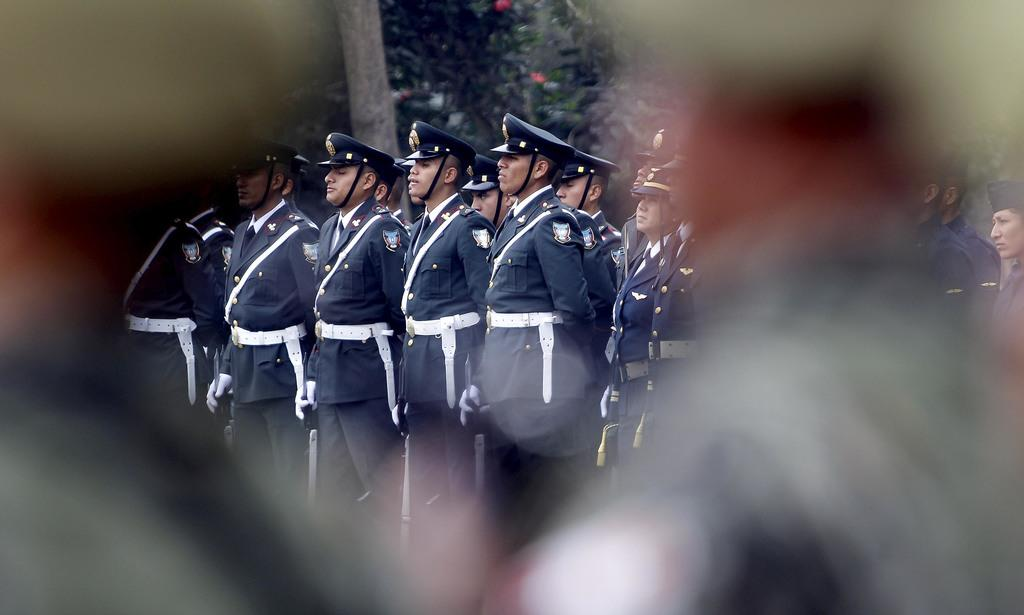Who or what can be seen in the image? There are people in the image. What are the people wearing? The people are wearing uniforms. What can be seen in the distance behind the people? There are trees in the background of the image. What type of yak is grazing in the foreground of the image? There is no yak present in the image; it features people wearing uniforms with trees in the background. 